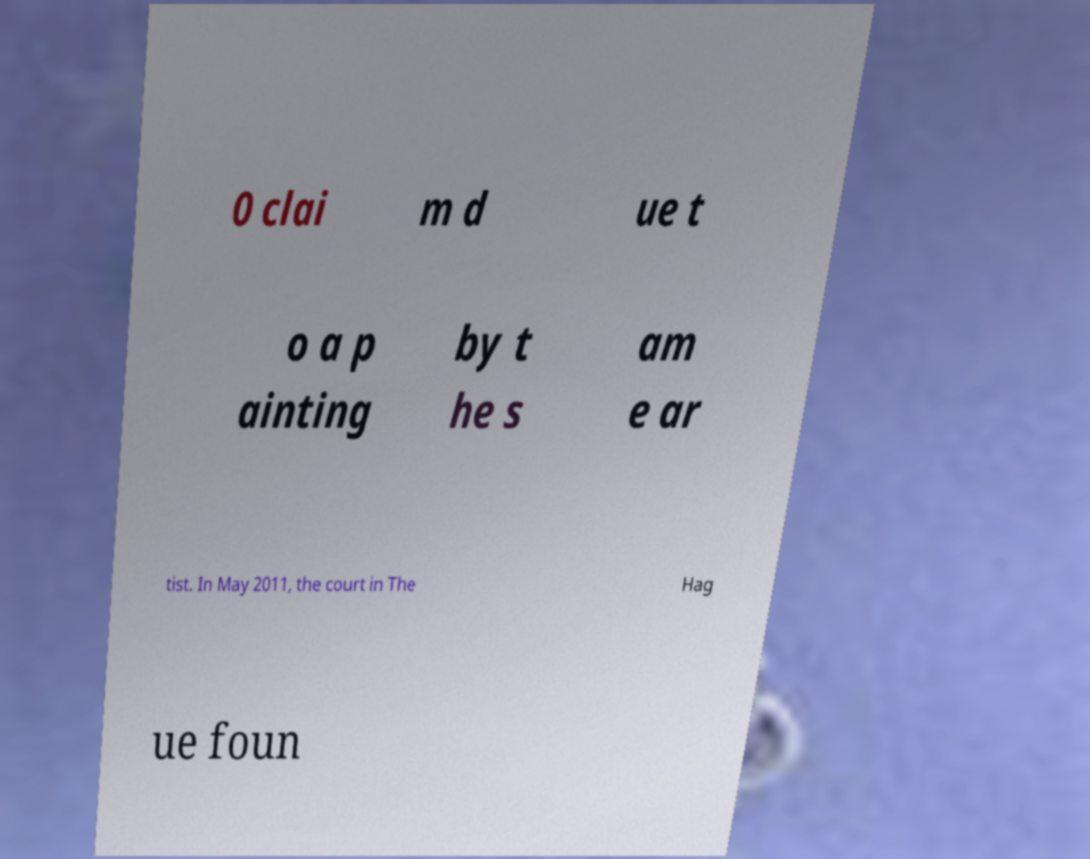Could you assist in decoding the text presented in this image and type it out clearly? 0 clai m d ue t o a p ainting by t he s am e ar tist. In May 2011, the court in The Hag ue foun 